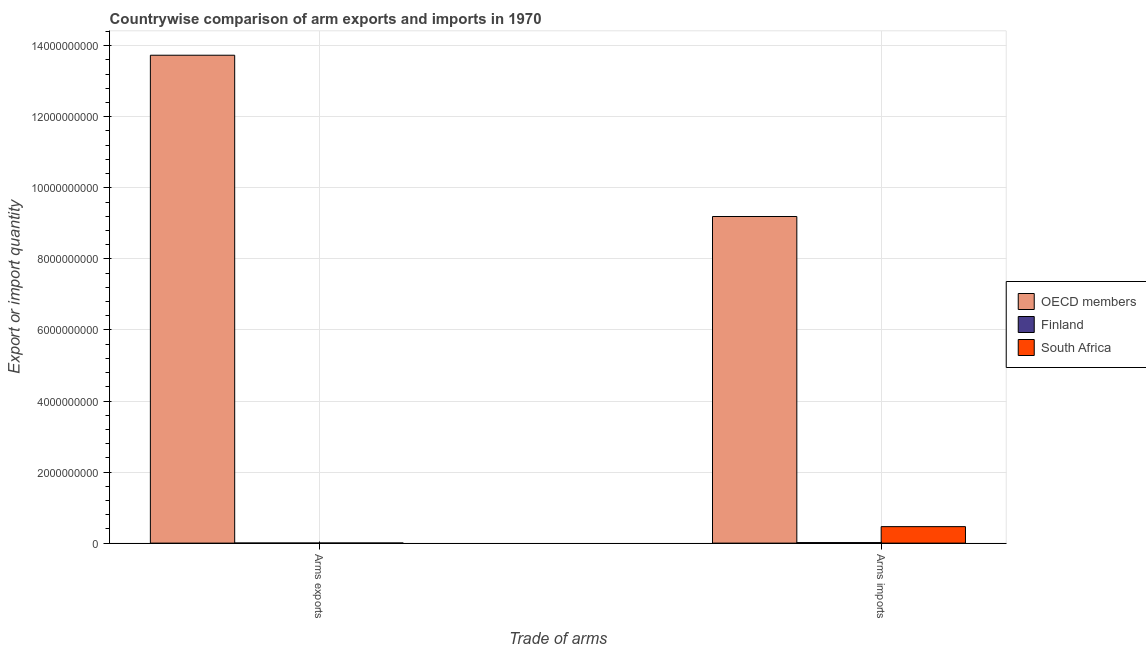How many groups of bars are there?
Your response must be concise. 2. Are the number of bars on each tick of the X-axis equal?
Provide a short and direct response. Yes. What is the label of the 1st group of bars from the left?
Keep it short and to the point. Arms exports. What is the arms exports in South Africa?
Give a very brief answer. 3.00e+06. Across all countries, what is the maximum arms exports?
Ensure brevity in your answer.  1.37e+1. Across all countries, what is the minimum arms exports?
Ensure brevity in your answer.  2.00e+06. In which country was the arms imports minimum?
Your answer should be compact. Finland. What is the total arms imports in the graph?
Your answer should be compact. 9.67e+09. What is the difference between the arms imports in Finland and that in South Africa?
Make the answer very short. -4.49e+08. What is the difference between the arms exports in Finland and the arms imports in South Africa?
Keep it short and to the point. -4.62e+08. What is the average arms imports per country?
Ensure brevity in your answer.  3.22e+09. What is the difference between the arms imports and arms exports in Finland?
Ensure brevity in your answer.  1.30e+07. What is the ratio of the arms exports in South Africa to that in OECD members?
Give a very brief answer. 0. Is the arms exports in South Africa less than that in OECD members?
Your response must be concise. Yes. In how many countries, is the arms exports greater than the average arms exports taken over all countries?
Provide a short and direct response. 1. What does the 2nd bar from the left in Arms imports represents?
Offer a very short reply. Finland. What does the 2nd bar from the right in Arms exports represents?
Your answer should be compact. Finland. Are the values on the major ticks of Y-axis written in scientific E-notation?
Offer a terse response. No. Does the graph contain grids?
Offer a terse response. Yes. Where does the legend appear in the graph?
Offer a very short reply. Center right. How many legend labels are there?
Keep it short and to the point. 3. What is the title of the graph?
Offer a very short reply. Countrywise comparison of arm exports and imports in 1970. What is the label or title of the X-axis?
Provide a succinct answer. Trade of arms. What is the label or title of the Y-axis?
Give a very brief answer. Export or import quantity. What is the Export or import quantity in OECD members in Arms exports?
Offer a terse response. 1.37e+1. What is the Export or import quantity in OECD members in Arms imports?
Offer a very short reply. 9.19e+09. What is the Export or import quantity in Finland in Arms imports?
Make the answer very short. 1.50e+07. What is the Export or import quantity in South Africa in Arms imports?
Provide a succinct answer. 4.64e+08. Across all Trade of arms, what is the maximum Export or import quantity in OECD members?
Offer a very short reply. 1.37e+1. Across all Trade of arms, what is the maximum Export or import quantity in Finland?
Make the answer very short. 1.50e+07. Across all Trade of arms, what is the maximum Export or import quantity of South Africa?
Offer a very short reply. 4.64e+08. Across all Trade of arms, what is the minimum Export or import quantity in OECD members?
Provide a short and direct response. 9.19e+09. Across all Trade of arms, what is the minimum Export or import quantity in Finland?
Your answer should be very brief. 2.00e+06. Across all Trade of arms, what is the minimum Export or import quantity of South Africa?
Offer a very short reply. 3.00e+06. What is the total Export or import quantity of OECD members in the graph?
Keep it short and to the point. 2.29e+1. What is the total Export or import quantity in Finland in the graph?
Give a very brief answer. 1.70e+07. What is the total Export or import quantity of South Africa in the graph?
Your answer should be very brief. 4.67e+08. What is the difference between the Export or import quantity of OECD members in Arms exports and that in Arms imports?
Your answer should be very brief. 4.54e+09. What is the difference between the Export or import quantity in Finland in Arms exports and that in Arms imports?
Your answer should be compact. -1.30e+07. What is the difference between the Export or import quantity of South Africa in Arms exports and that in Arms imports?
Offer a terse response. -4.61e+08. What is the difference between the Export or import quantity of OECD members in Arms exports and the Export or import quantity of Finland in Arms imports?
Offer a terse response. 1.37e+1. What is the difference between the Export or import quantity in OECD members in Arms exports and the Export or import quantity in South Africa in Arms imports?
Make the answer very short. 1.33e+1. What is the difference between the Export or import quantity of Finland in Arms exports and the Export or import quantity of South Africa in Arms imports?
Keep it short and to the point. -4.62e+08. What is the average Export or import quantity in OECD members per Trade of arms?
Give a very brief answer. 1.15e+1. What is the average Export or import quantity in Finland per Trade of arms?
Your response must be concise. 8.50e+06. What is the average Export or import quantity in South Africa per Trade of arms?
Provide a short and direct response. 2.34e+08. What is the difference between the Export or import quantity of OECD members and Export or import quantity of Finland in Arms exports?
Make the answer very short. 1.37e+1. What is the difference between the Export or import quantity in OECD members and Export or import quantity in South Africa in Arms exports?
Keep it short and to the point. 1.37e+1. What is the difference between the Export or import quantity in Finland and Export or import quantity in South Africa in Arms exports?
Offer a terse response. -1.00e+06. What is the difference between the Export or import quantity in OECD members and Export or import quantity in Finland in Arms imports?
Give a very brief answer. 9.18e+09. What is the difference between the Export or import quantity of OECD members and Export or import quantity of South Africa in Arms imports?
Offer a terse response. 8.73e+09. What is the difference between the Export or import quantity of Finland and Export or import quantity of South Africa in Arms imports?
Give a very brief answer. -4.49e+08. What is the ratio of the Export or import quantity in OECD members in Arms exports to that in Arms imports?
Give a very brief answer. 1.49. What is the ratio of the Export or import quantity in Finland in Arms exports to that in Arms imports?
Keep it short and to the point. 0.13. What is the ratio of the Export or import quantity of South Africa in Arms exports to that in Arms imports?
Offer a terse response. 0.01. What is the difference between the highest and the second highest Export or import quantity of OECD members?
Keep it short and to the point. 4.54e+09. What is the difference between the highest and the second highest Export or import quantity in Finland?
Offer a terse response. 1.30e+07. What is the difference between the highest and the second highest Export or import quantity of South Africa?
Offer a terse response. 4.61e+08. What is the difference between the highest and the lowest Export or import quantity in OECD members?
Make the answer very short. 4.54e+09. What is the difference between the highest and the lowest Export or import quantity of Finland?
Your answer should be very brief. 1.30e+07. What is the difference between the highest and the lowest Export or import quantity in South Africa?
Your answer should be very brief. 4.61e+08. 